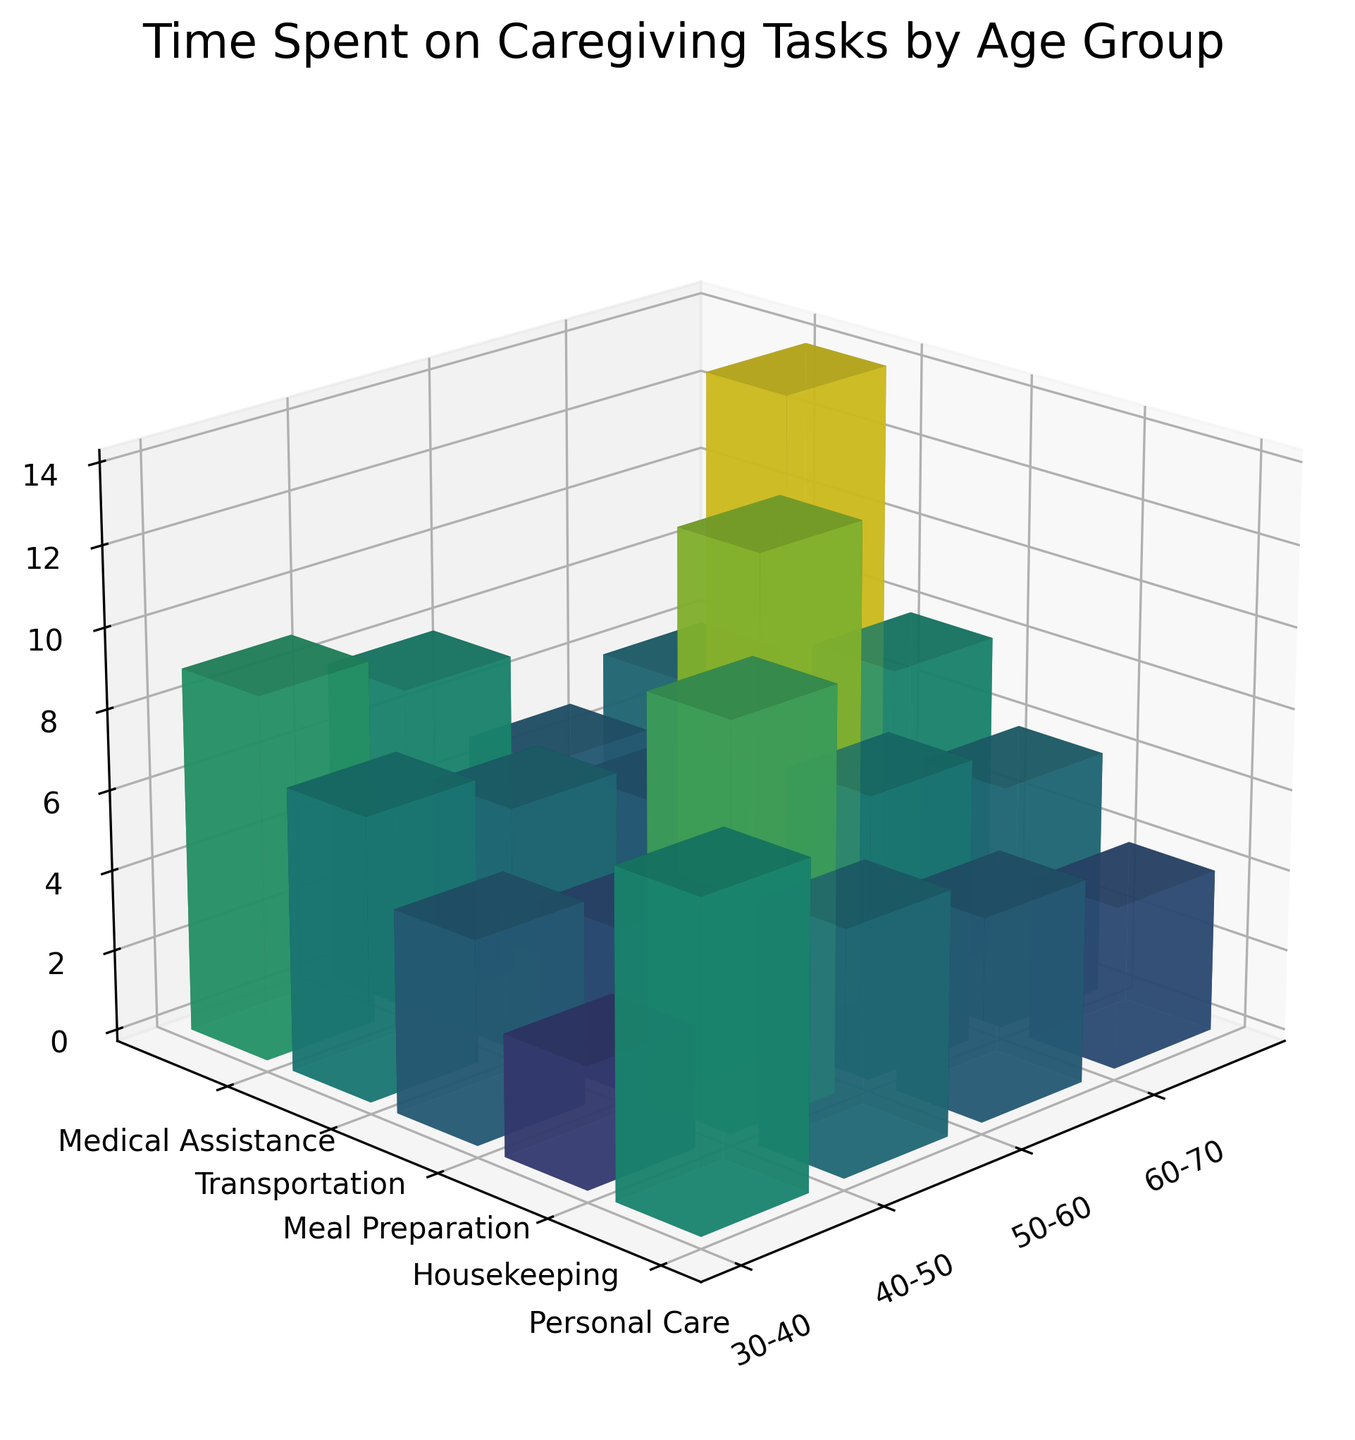What is the title of the plot? The title of the plot can be found at the top of the figure. It typically provides an overall summary of what the plot is about. In this case, it reads 'Time Spent on Caregiving Tasks by Age Group'.
Answer: Time Spent on Caregiving Tasks by Age Group Which age group spends the most time on Personal Care? To find this, look at the 'Personal Care' section on the y-axis and identify which bar is highest along the z-axis. The age group 60-70 has the highest bar for Personal Care.
Answer: 60-70 How many hours per week does the 50-60 age group spend on Medical Assistance? Find the 'Medical Assistance' section on the y-axis, then look for the bar corresponding to the 50-60 age group on the x-axis. The height of the bar indicates the hours, which is 5.
Answer: 5 What is the total time spent on Meal Preparation by all age groups combined? Sum the heights of the bars in the 'Meal Preparation' section for each age group. For 30-40: 5, 40-50: 6, 50-60: 7, 60-70: 8. Sum these values: 5 + 6 + 7 + 8 = 26 hours.
Answer: 26 Which task has the smallest difference in time spent between the 30-40 age group and the 60-70 age group? Calculate the differences for each task:
- Personal Care: 14 - 8 = 6
- Housekeeping: 9 - 6 = 3
- Meal Preparation: 8 - 5 = 3
- Transportation: 5 - 4 = 1
- Medical Assistance: 6 - 3 = 3
The smallest difference is in Transportation.
Answer: Transportation On average, how much time does the 40-50 age group spend per week across all tasks? Sum the hours for the 40-50 age group and divide by the number of tasks:
- Total: 10 (Personal Care) + 7 (Housekeeping) + 6 (Meal Preparation) + 5 (Transportation) + 4 (Medical Assistance) = 32
- Average: 32 / 5 = 6.4 hours.
Answer: 6.4 Which two tasks have the same number of hours spent per week by the 50-60 age group? Look for bars of the same height within the 50-60 age group. Both Housekeeping and Transportation have bars of equal height, which is 8 hours.
Answer: Housekeeping and Transportation Is the time spent on Housekeeping generally increasing or decreasing with age? By observing the height of the Housekeeping bars from left (younger) to right (older) along the x-axis, we can see that the bars increase in height: 6, 7, 8, 9. This indicates an increasing trend.
Answer: Increasing What is the highest number of hours spent on any task by any age group? Identify the tallest bar in the plot across all tasks and age groups, which is the Personal Care bar for the 60-70 age group, at 14 hours.
Answer: 14 